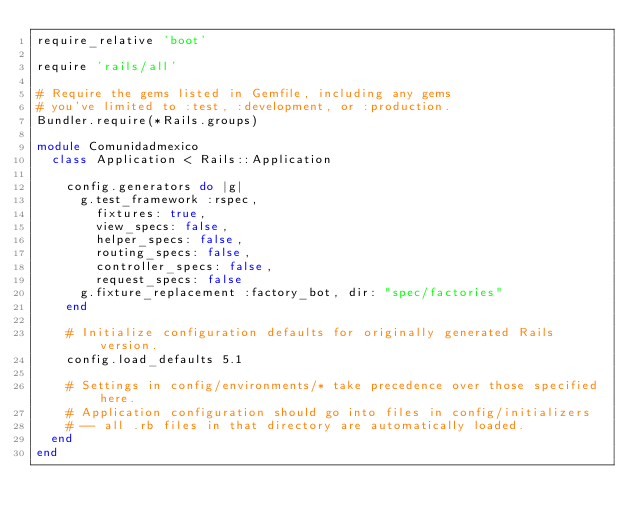Convert code to text. <code><loc_0><loc_0><loc_500><loc_500><_Ruby_>require_relative 'boot'

require 'rails/all'

# Require the gems listed in Gemfile, including any gems
# you've limited to :test, :development, or :production.
Bundler.require(*Rails.groups)

module Comunidadmexico
  class Application < Rails::Application

    config.generators do |g|
      g.test_framework :rspec,
        fixtures: true,
        view_specs: false,
        helper_specs: false,
        routing_specs: false,
        controller_specs: false,
        request_specs: false
      g.fixture_replacement :factory_bot, dir: "spec/factories"
    end

    # Initialize configuration defaults for originally generated Rails version.
    config.load_defaults 5.1

    # Settings in config/environments/* take precedence over those specified here.
    # Application configuration should go into files in config/initializers
    # -- all .rb files in that directory are automatically loaded.
  end
end
</code> 